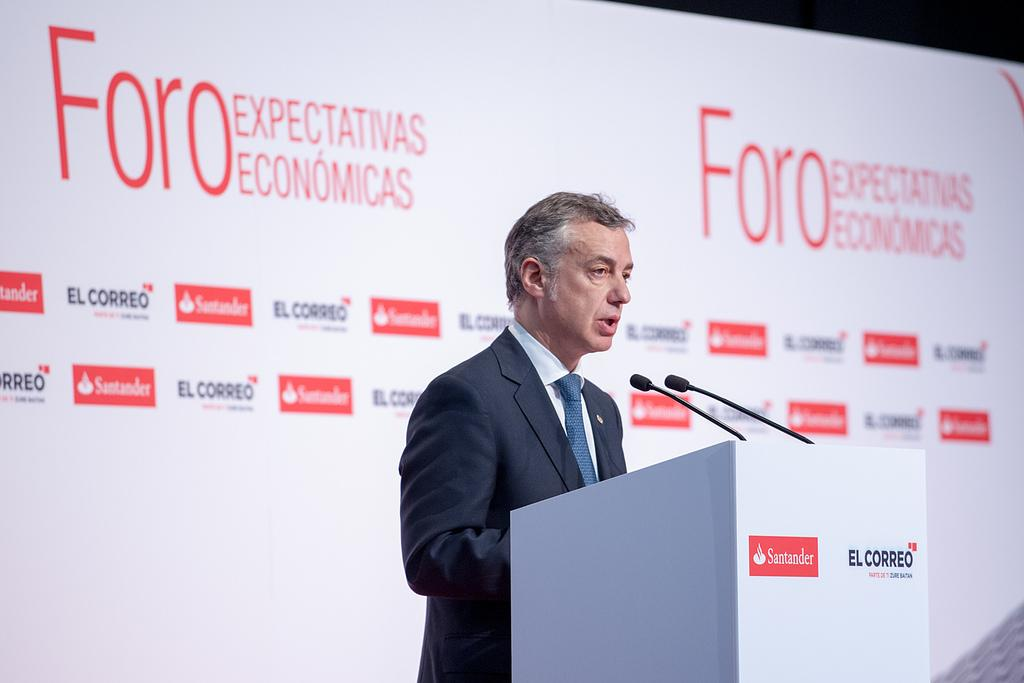Who or what is in the image? There is a person in the image. What is the person doing or standing near in the image? The person is in front of a podium. What can be seen in the background of the image? There is a cardboard banner in the background of the image. What type of blood is visible on the person's hands in the image? There is no blood visible on the person's hands in the image. 